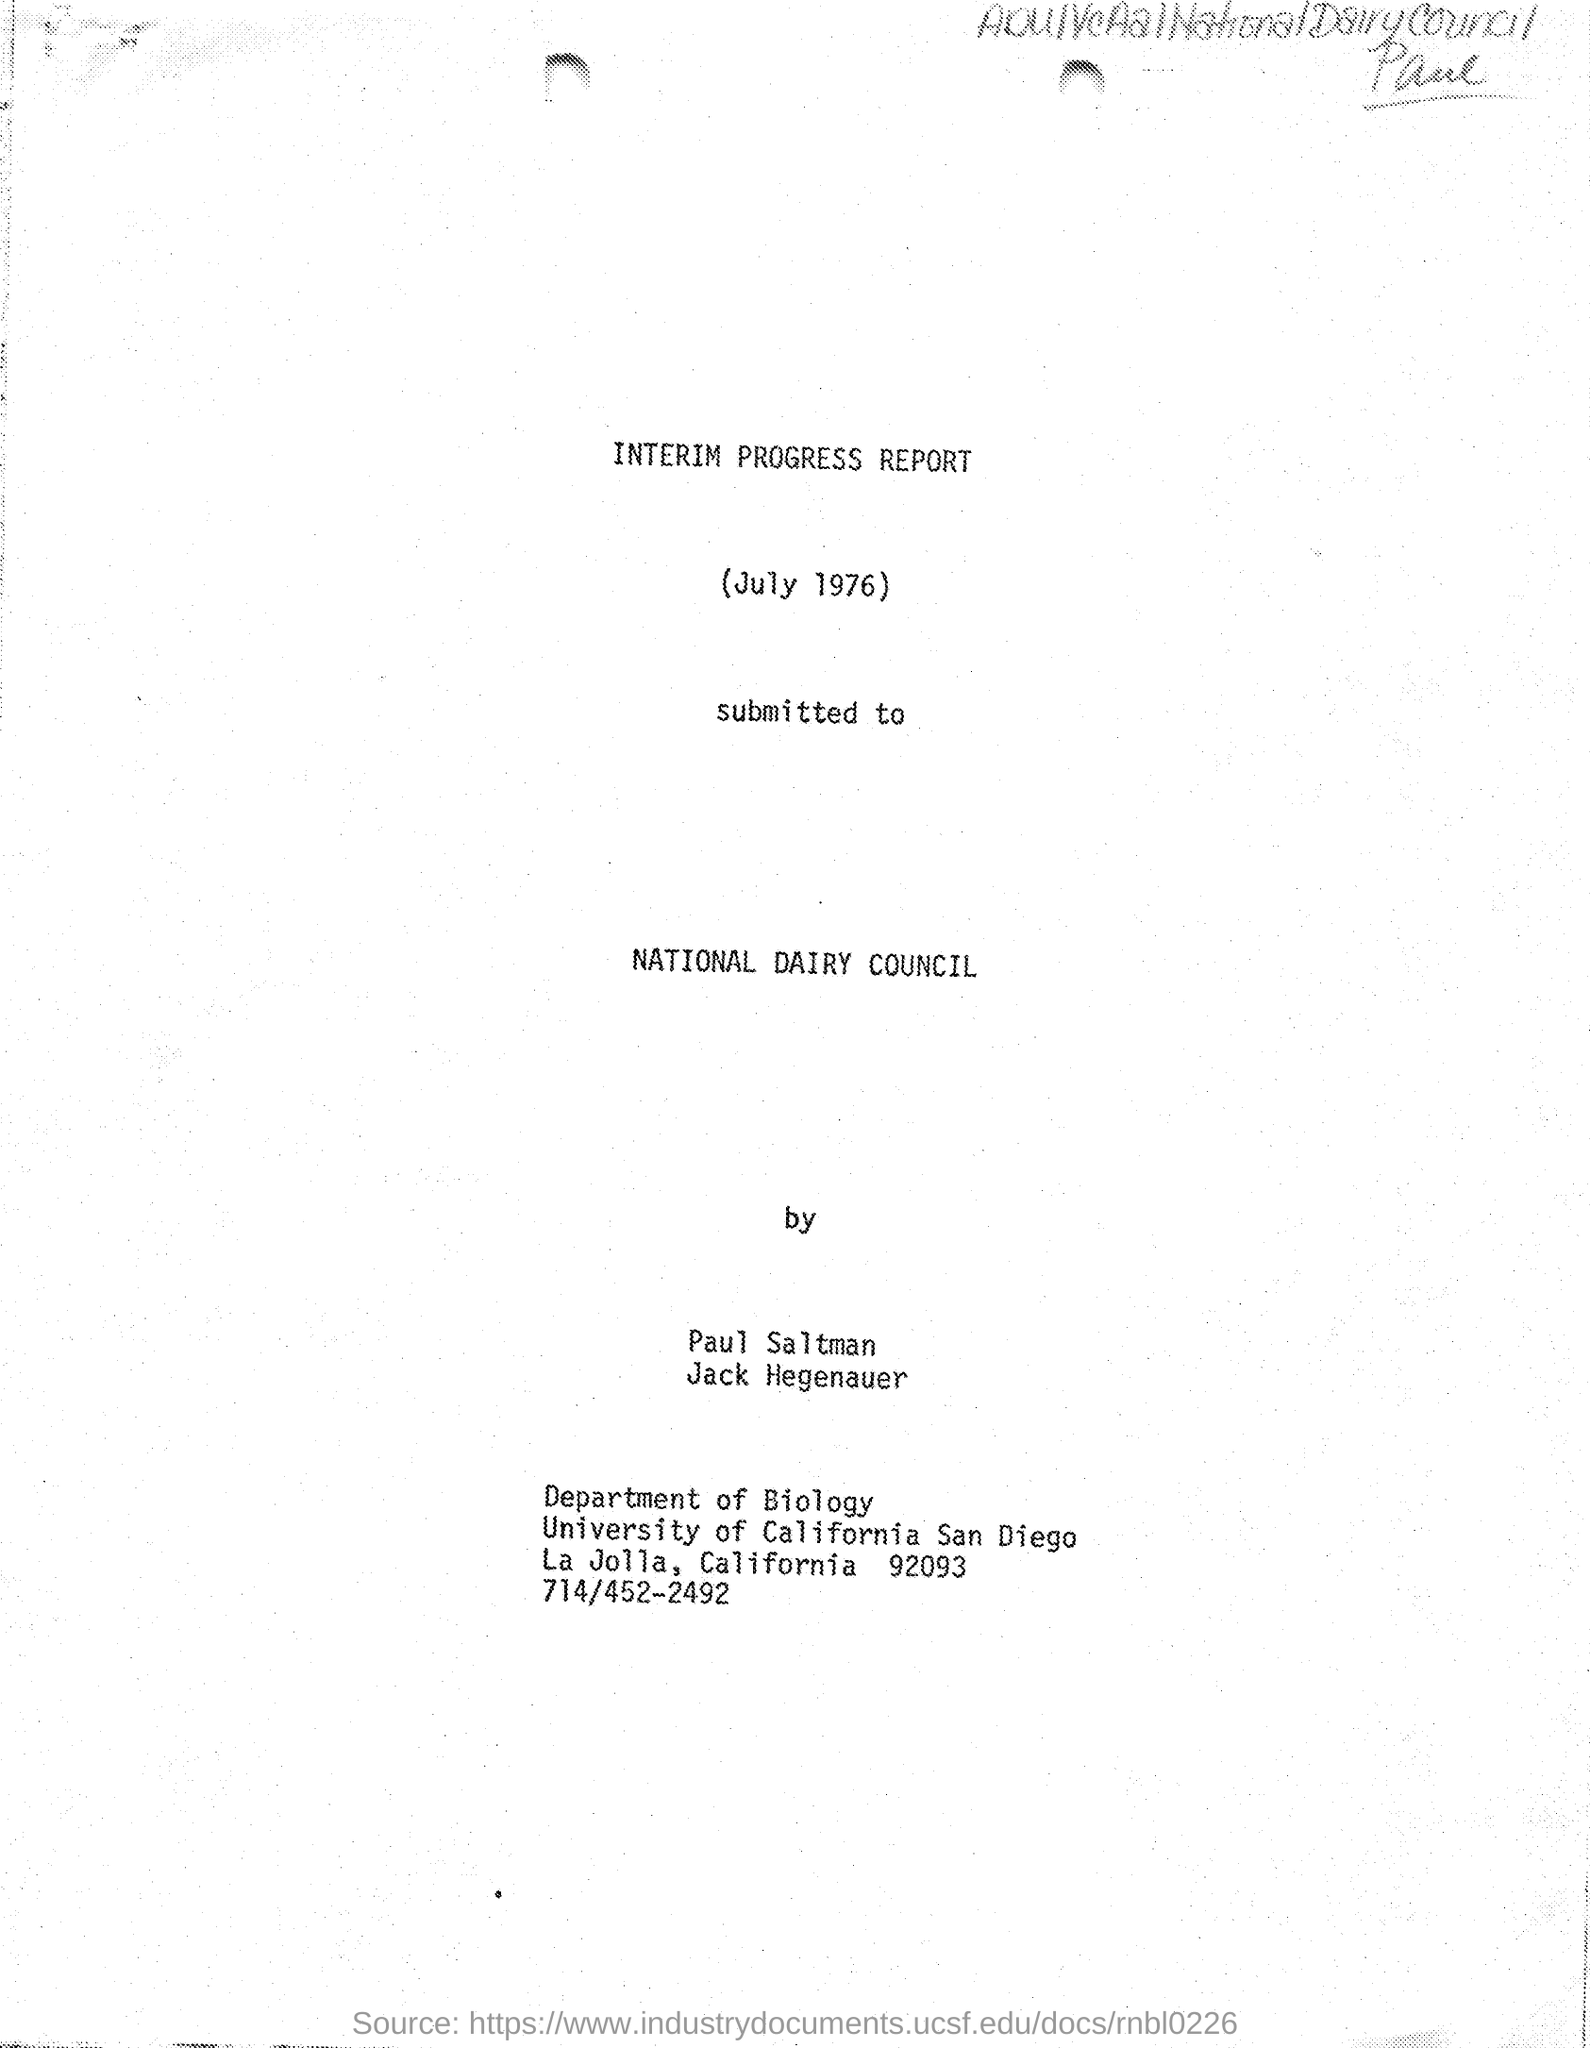Mention a couple of crucial points in this snapshot. The letter was submitted to the National Dairy Council. The phone number mentioned in the given letter is 714/452-2492. The date mentioned in the given letter is July 1976. The department mentioned in the given letter is the Department of Biology. This is an interim progress report. 